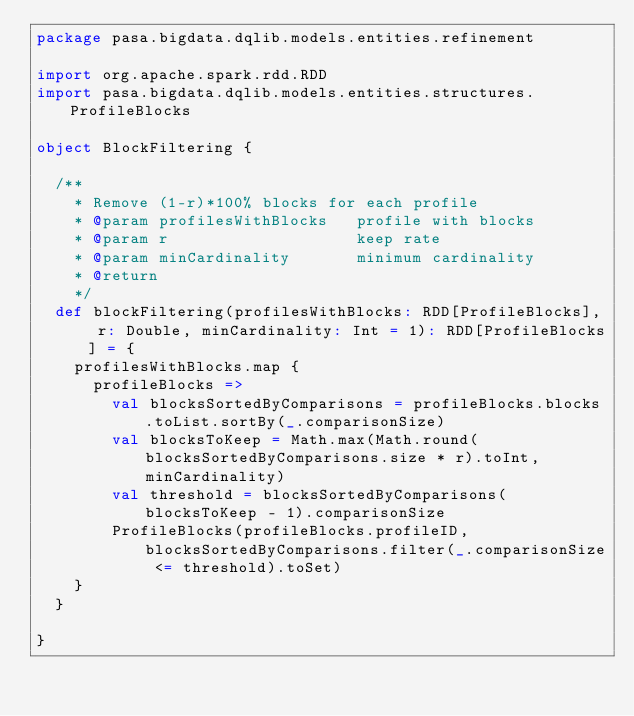Convert code to text. <code><loc_0><loc_0><loc_500><loc_500><_Scala_>package pasa.bigdata.dqlib.models.entities.refinement

import org.apache.spark.rdd.RDD
import pasa.bigdata.dqlib.models.entities.structures.ProfileBlocks

object BlockFiltering {

  /**
    * Remove (1-r)*100% blocks for each profile
    * @param profilesWithBlocks   profile with blocks
    * @param r                    keep rate
    * @param minCardinality       minimum cardinality
    * @return
    */
  def blockFiltering(profilesWithBlocks: RDD[ProfileBlocks], r: Double, minCardinality: Int = 1): RDD[ProfileBlocks] = {
    profilesWithBlocks.map {
      profileBlocks =>
        val blocksSortedByComparisons = profileBlocks.blocks.toList.sortBy(_.comparisonSize)
        val blocksToKeep = Math.max(Math.round(blocksSortedByComparisons.size * r).toInt, minCardinality)
        val threshold = blocksSortedByComparisons(blocksToKeep - 1).comparisonSize
        ProfileBlocks(profileBlocks.profileID, blocksSortedByComparisons.filter(_.comparisonSize <= threshold).toSet)
    }
  }

}
</code> 